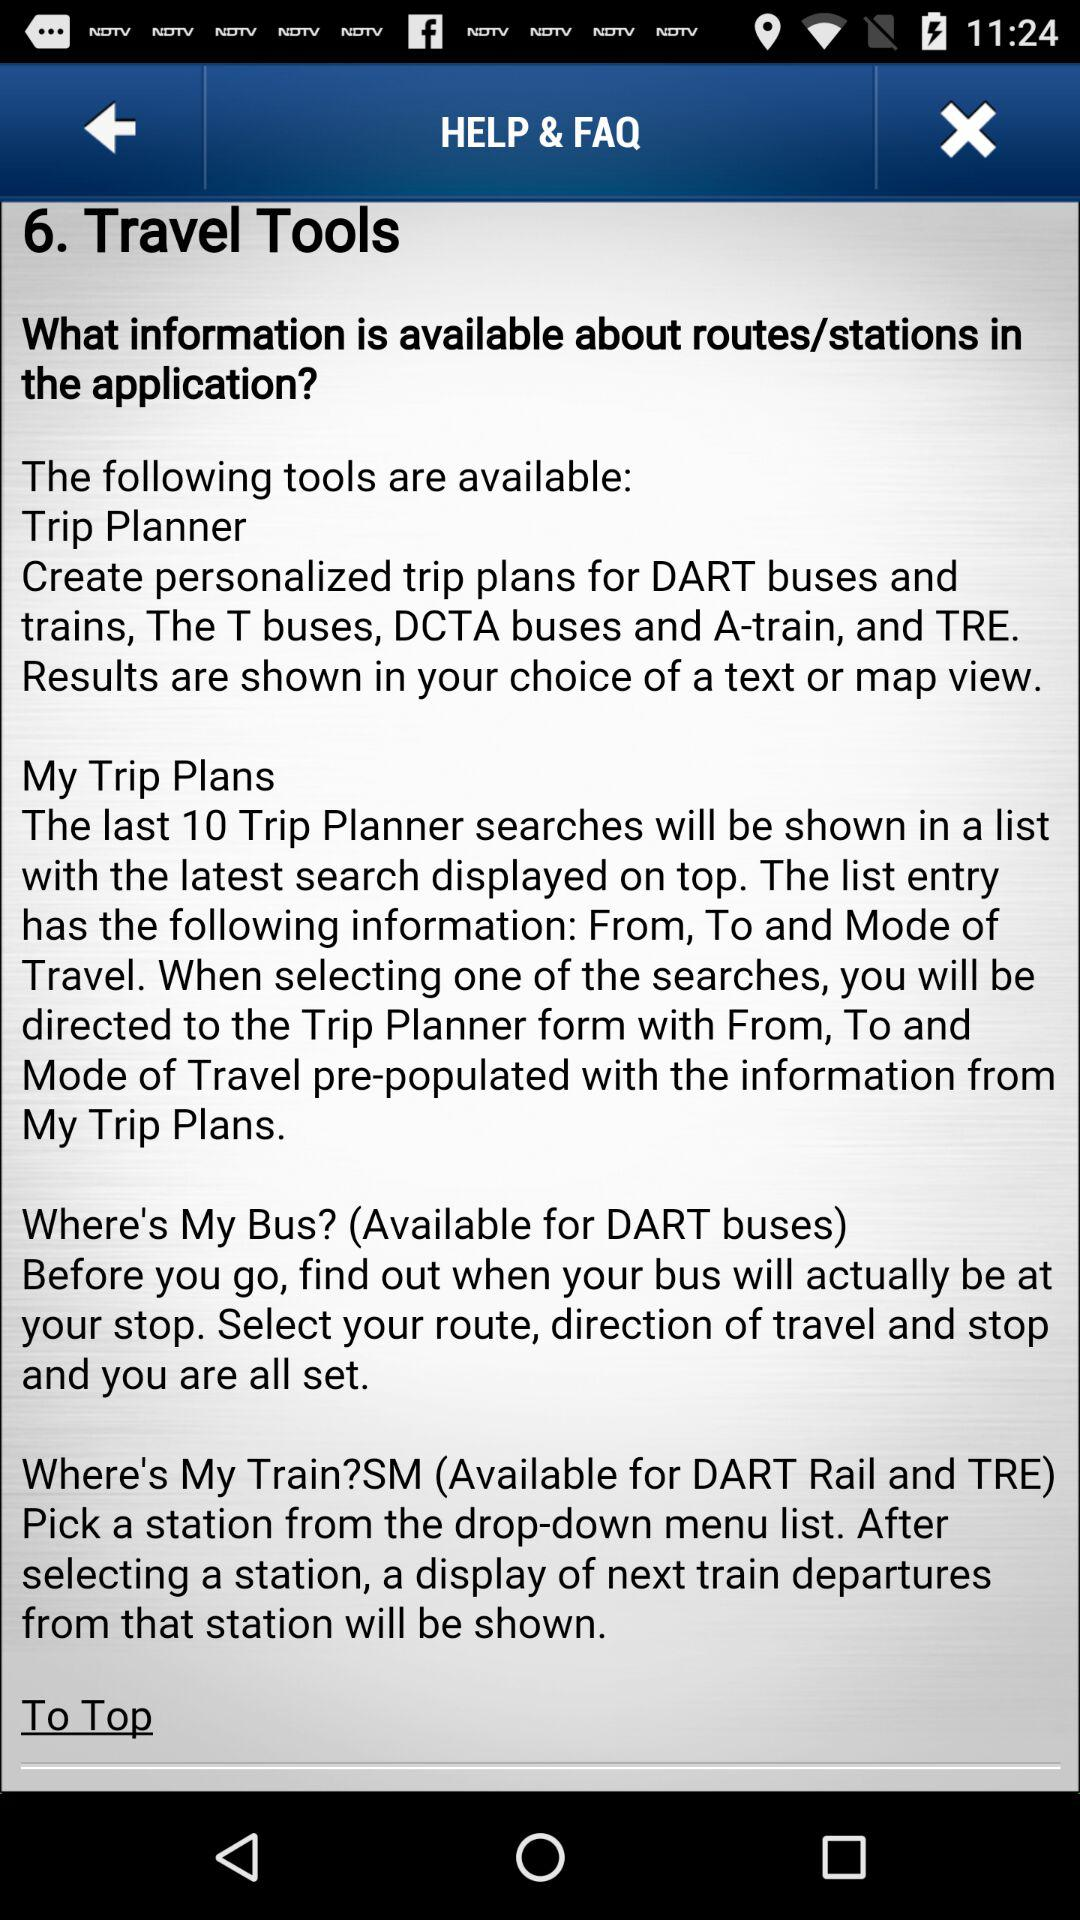How many tools are available in the Travel Tools section?
Answer the question using a single word or phrase. 4 